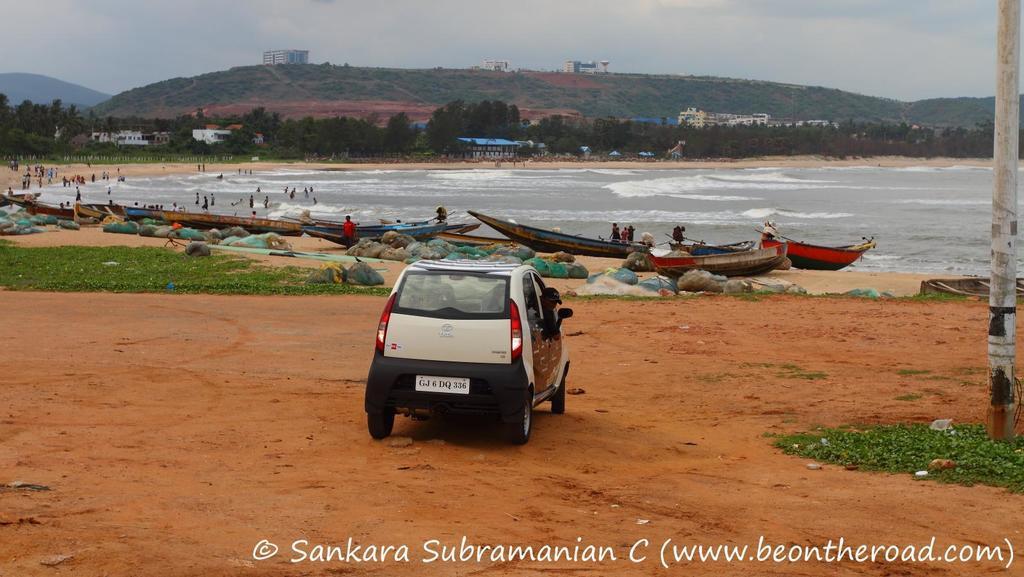In one or two sentences, can you explain what this image depicts? As we can see in the image there is a car, grass, boats, water, few people here and there, trees, buildings, hills and sky. 